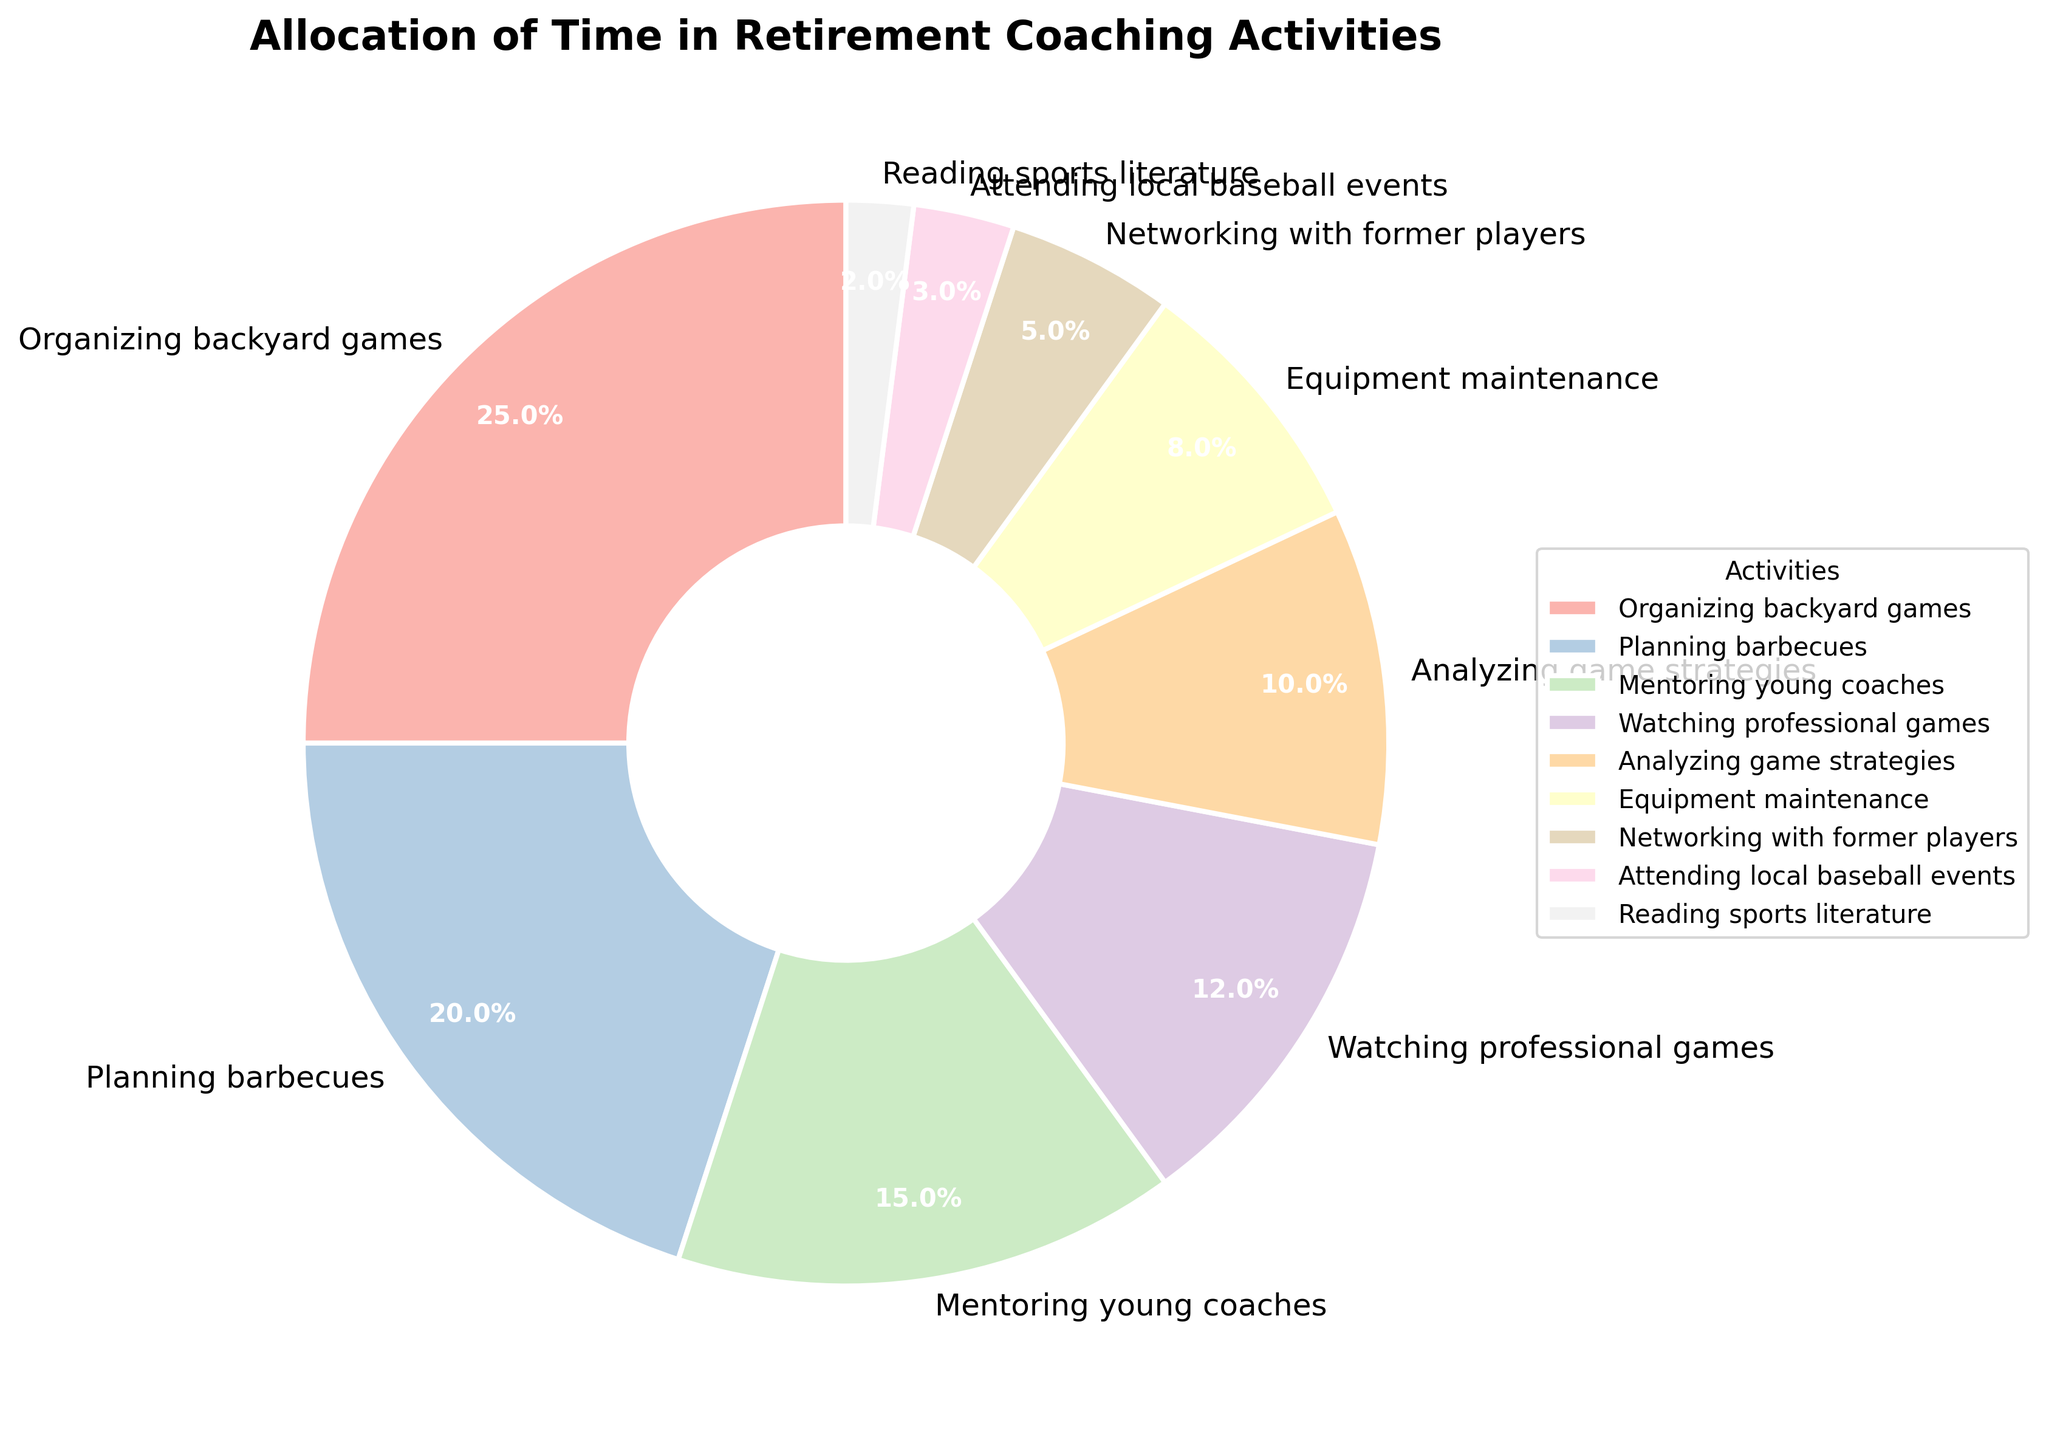What percentage of time is spent on organizing backyard games? The figure shows a segment labeled "Organizing backyard games" with a percentage indicated.
Answer: 25% Which activity takes up more time, planning barbecues or analyzing game strategies? Comparing the percentages of "Planning barbecues" and "Analyzing game strategies", we see that planning barbecues is 20% and analyzing game strategies is 10%.
Answer: Planning barbecues What is the combined percentage of time spent on mentoring young coaches and watching professional games? Mentoring young coaches takes up 15% and watching professional games takes up 12%. Adding them together gives 15% + 12%.
Answer: 27% How much more time is spent on equipment maintenance compared to attending local baseball events? Equipment maintenance has a percentage of 8%, and attending local baseball events has 3%. The difference between them is 8% - 3%.
Answer: 5% List the activities that take up less than 10% of the time each. The figure shows that equipment maintenance (8%), networking with former players (5%), attending local baseball events (3%), and reading sports literature (2%) are each under 10%.
Answer: Equipment maintenance, Networking with former players, Attending local baseball events, Reading sports literature Which activity is allocated the least time? The segment with the smallest percentage is "Reading sports literature" at 2%.
Answer: Reading sports literature Are there more activities that occupy greater than or equal to 10% of time or less than 10% of time? Activities greater than or equal to 10% are organizing backyard games (25%), planning barbecues (20%), mentoring young coaches (15%), watching professional games (12%), analyzing game strategies (10%). Activities less than 10% are equipment maintenance (8%), networking with former players (5%), attending local baseball events (3%), reading sports literature (2%). There are 5 activities >= 10% and 4 activities < 10%.
Answer: Greater than or equal to 10% What is the total percentage of time spent on activities related to games (organizing backyard games, watching professional games, analyzing game strategies)? Adding the percentages for organizing backyard games (25%), watching professional games (12%), and analyzing game strategies (10%) gives 25% + 12% + 10%.
Answer: 47% If mentoring young coaches and watching professional games were combined into one activity, what percentage would that activity represent? Adding the percentages for mentoring young coaches (15%) and watching professional games (12%) would be 15% + 12%.
Answer: 27% What percentage of time is not spent on either planning barbecues or organizing backyard games? The total percentage for planning barbecues and organizing backyard games is 20% + 25%, totaling 45%. Subtracting this from 100% gives 100% - 45%.
Answer: 55% 